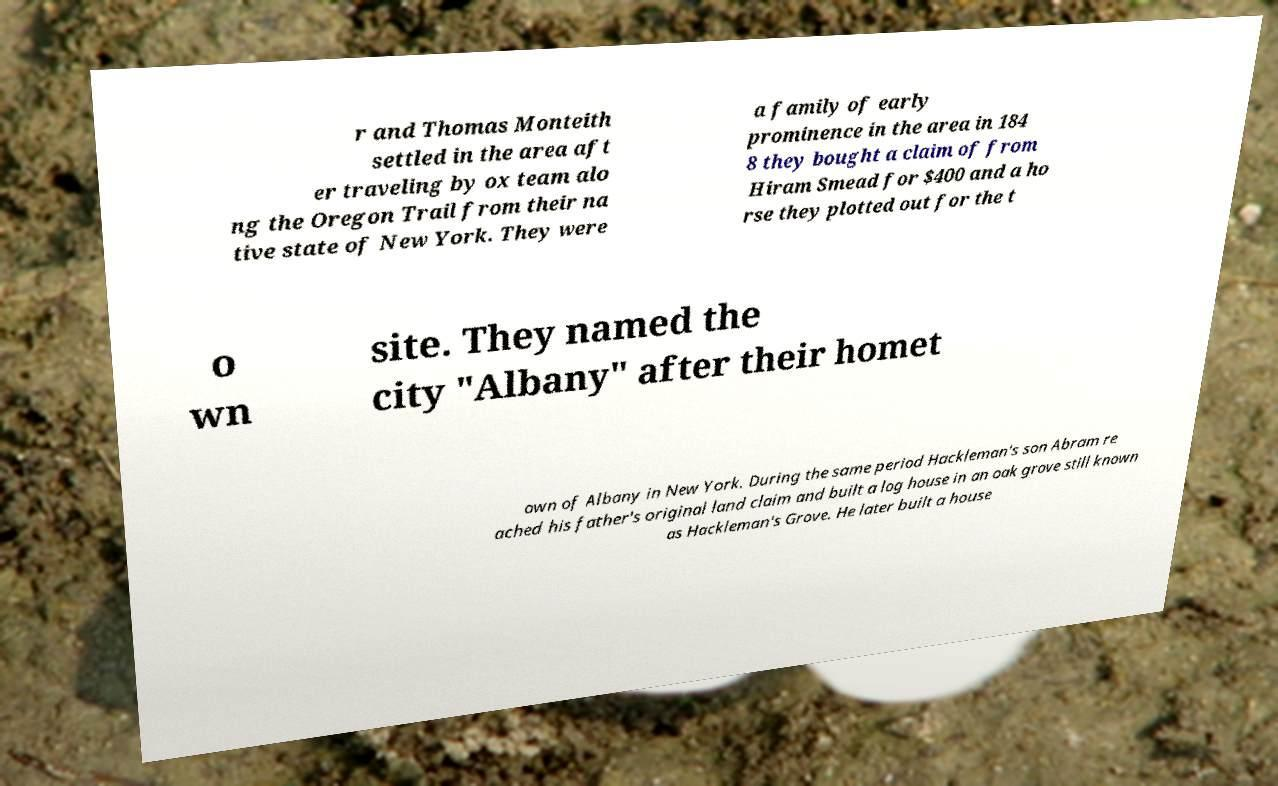Please identify and transcribe the text found in this image. r and Thomas Monteith settled in the area aft er traveling by ox team alo ng the Oregon Trail from their na tive state of New York. They were a family of early prominence in the area in 184 8 they bought a claim of from Hiram Smead for $400 and a ho rse they plotted out for the t o wn site. They named the city "Albany" after their homet own of Albany in New York. During the same period Hackleman's son Abram re ached his father's original land claim and built a log house in an oak grove still known as Hackleman's Grove. He later built a house 